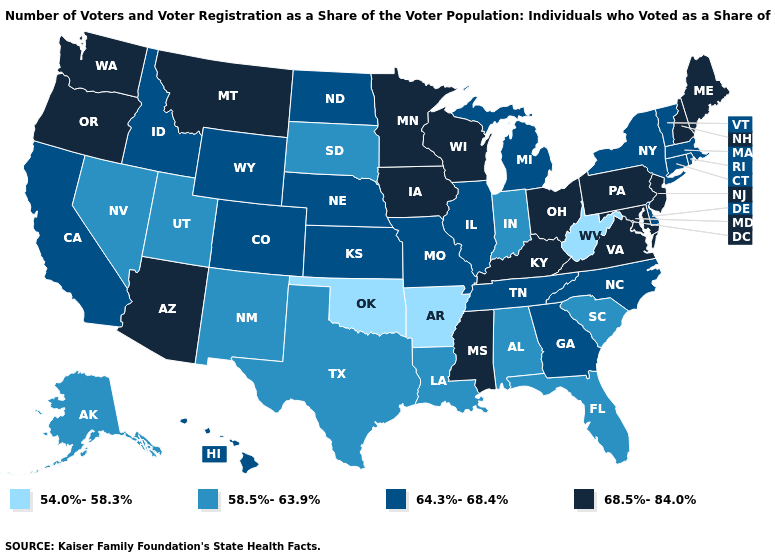Among the states that border Delaware , which have the lowest value?
Concise answer only. Maryland, New Jersey, Pennsylvania. What is the value of Alabama?
Give a very brief answer. 58.5%-63.9%. Name the states that have a value in the range 58.5%-63.9%?
Short answer required. Alabama, Alaska, Florida, Indiana, Louisiana, Nevada, New Mexico, South Carolina, South Dakota, Texas, Utah. Does Hawaii have the lowest value in the West?
Give a very brief answer. No. Name the states that have a value in the range 58.5%-63.9%?
Write a very short answer. Alabama, Alaska, Florida, Indiana, Louisiana, Nevada, New Mexico, South Carolina, South Dakota, Texas, Utah. Does the first symbol in the legend represent the smallest category?
Answer briefly. Yes. Does Louisiana have the lowest value in the USA?
Write a very short answer. No. What is the lowest value in the USA?
Be succinct. 54.0%-58.3%. What is the value of Maine?
Write a very short answer. 68.5%-84.0%. Does Hawaii have the highest value in the West?
Concise answer only. No. Is the legend a continuous bar?
Write a very short answer. No. Which states have the lowest value in the USA?
Answer briefly. Arkansas, Oklahoma, West Virginia. Does Oklahoma have the lowest value in the South?
Write a very short answer. Yes. What is the highest value in the South ?
Quick response, please. 68.5%-84.0%. Is the legend a continuous bar?
Short answer required. No. 